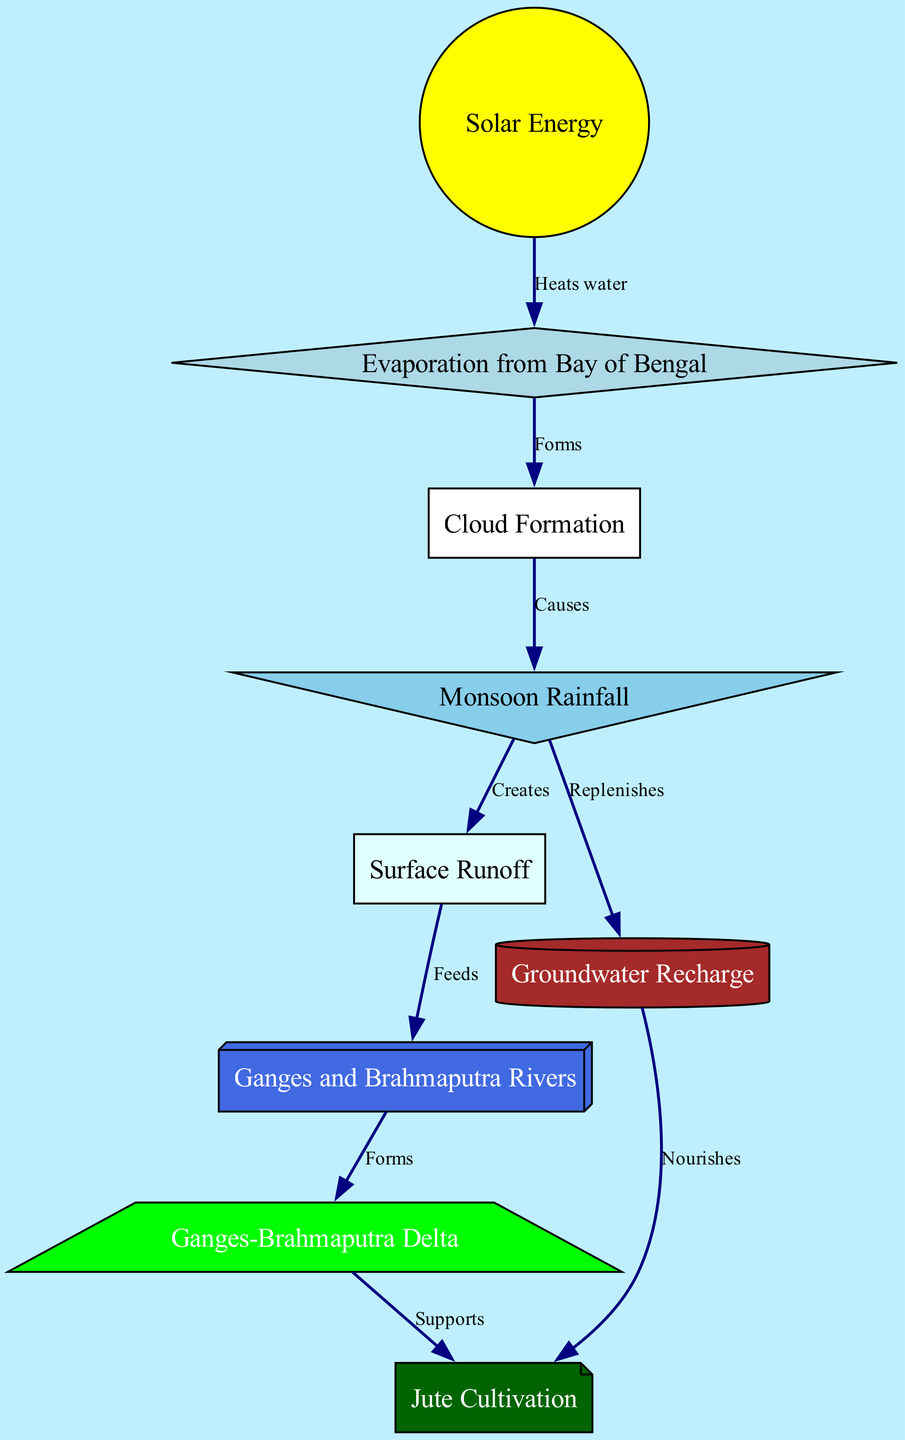What causes cloud formation? The diagram indicates that cloud formation is caused by evaporation from the Bay of Bengal, which is heated by solar energy. This process is depicted by the connection between the nodes for solar energy, evaporation, and clouds.
Answer: Evaporation from Bay of Bengal What supports jute cultivation in the diagram? Jute cultivation is supported by the Ganges-Brahmaputra Delta, as indicated by the arrow connecting the delta node to the jute node in the diagram.
Answer: Ganges-Brahmaputra Delta How many nodes are there in the diagram? By counting all nodes listed in the diagram, we find there are nine distinct nodes, which represent different elements of the water cycle and its impact on jute cultivation.
Answer: Nine What role does precipitation play in groundwater recharge? The diagram shows that precipitation replenishes groundwater, illustrating the direct connection between these two nodes. This indicates that the water falling as rain contributes to the groundwater supply.
Answer: Replenishes Which process feeds the Ganges and Brahmaputra Rivers? The diagram states that surface runoff feeds the Ganges and Brahmaputra Rivers, as indicated by the connection from the runoff node to the rivers node.
Answer: Surface Runoff What is the relationship between groundwater and jute cultivation? According to the diagram, groundwater nourishes jute cultivation, demonstrating the importance of groundwater for the growth of jute plants.
Answer: Nourishes What is formed by the rivers in the water cycle? The Ganges and Brahmaputra Rivers form the Ganges-Brahmaputra Delta as shown by the directed edge from the rivers node to the delta node in the diagram.
Answer: Ganges-Brahmaputra Delta What initiates the water cycle shown in the diagram? The diagram indicates that solar energy is the initial factor that heats water, which kickstarts the water cycle by leading to evaporation.
Answer: Solar Energy 